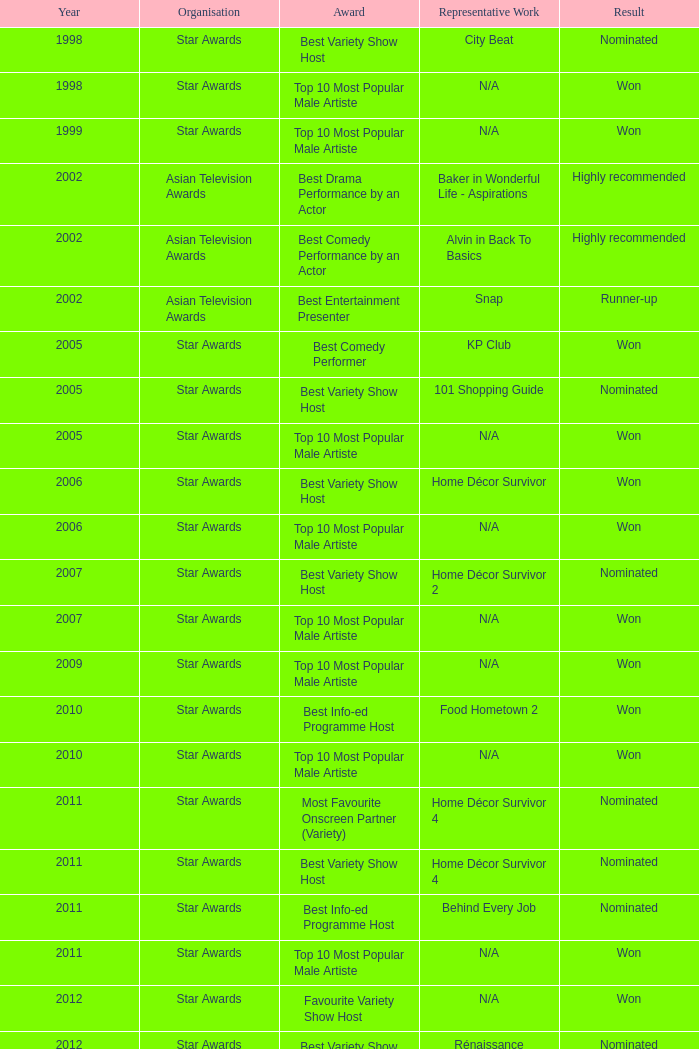In a year beyond 2005, what is the award's name and the nomination result? Best Variety Show Host, Most Favourite Onscreen Partner (Variety), Best Variety Show Host, Best Info-ed Programme Host, Best Variety Show Host, Best Info-ed Programme Host, Best Info-Ed Programme Host, Best Variety Show Host. 